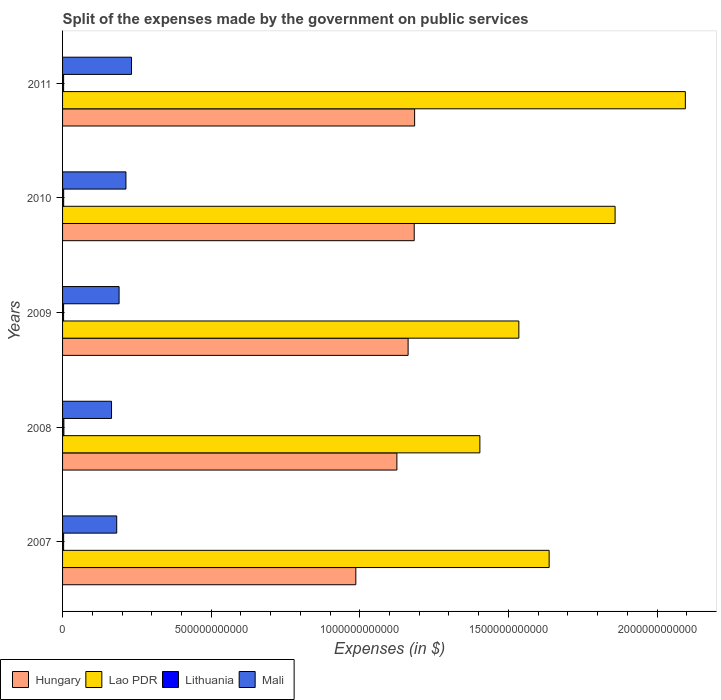How many different coloured bars are there?
Provide a succinct answer. 4. Are the number of bars per tick equal to the number of legend labels?
Make the answer very short. Yes. How many bars are there on the 4th tick from the bottom?
Your response must be concise. 4. What is the label of the 2nd group of bars from the top?
Provide a short and direct response. 2010. What is the expenses made by the government on public services in Mali in 2011?
Ensure brevity in your answer.  2.32e+11. Across all years, what is the maximum expenses made by the government on public services in Mali?
Keep it short and to the point. 2.32e+11. Across all years, what is the minimum expenses made by the government on public services in Lithuania?
Your answer should be very brief. 3.47e+09. In which year was the expenses made by the government on public services in Mali minimum?
Offer a terse response. 2008. What is the total expenses made by the government on public services in Mali in the graph?
Provide a short and direct response. 9.82e+11. What is the difference between the expenses made by the government on public services in Hungary in 2008 and that in 2009?
Give a very brief answer. -3.77e+1. What is the difference between the expenses made by the government on public services in Lithuania in 2010 and the expenses made by the government on public services in Hungary in 2007?
Provide a succinct answer. -9.83e+11. What is the average expenses made by the government on public services in Lao PDR per year?
Give a very brief answer. 1.71e+12. In the year 2008, what is the difference between the expenses made by the government on public services in Lao PDR and expenses made by the government on public services in Lithuania?
Ensure brevity in your answer.  1.40e+12. What is the ratio of the expenses made by the government on public services in Hungary in 2007 to that in 2011?
Provide a short and direct response. 0.83. Is the expenses made by the government on public services in Lao PDR in 2009 less than that in 2010?
Provide a short and direct response. Yes. Is the difference between the expenses made by the government on public services in Lao PDR in 2008 and 2011 greater than the difference between the expenses made by the government on public services in Lithuania in 2008 and 2011?
Offer a very short reply. No. What is the difference between the highest and the second highest expenses made by the government on public services in Lithuania?
Provide a short and direct response. 7.47e+08. What is the difference between the highest and the lowest expenses made by the government on public services in Lithuania?
Your answer should be compact. 9.76e+08. Is it the case that in every year, the sum of the expenses made by the government on public services in Mali and expenses made by the government on public services in Lao PDR is greater than the sum of expenses made by the government on public services in Hungary and expenses made by the government on public services in Lithuania?
Keep it short and to the point. Yes. What does the 3rd bar from the top in 2010 represents?
Your response must be concise. Lao PDR. What does the 3rd bar from the bottom in 2011 represents?
Provide a succinct answer. Lithuania. Is it the case that in every year, the sum of the expenses made by the government on public services in Lao PDR and expenses made by the government on public services in Lithuania is greater than the expenses made by the government on public services in Mali?
Keep it short and to the point. Yes. How many bars are there?
Make the answer very short. 20. Are all the bars in the graph horizontal?
Provide a succinct answer. Yes. What is the difference between two consecutive major ticks on the X-axis?
Give a very brief answer. 5.00e+11. What is the title of the graph?
Your answer should be compact. Split of the expenses made by the government on public services. What is the label or title of the X-axis?
Make the answer very short. Expenses (in $). What is the label or title of the Y-axis?
Give a very brief answer. Years. What is the Expenses (in $) of Hungary in 2007?
Your response must be concise. 9.87e+11. What is the Expenses (in $) in Lao PDR in 2007?
Offer a terse response. 1.64e+12. What is the Expenses (in $) in Lithuania in 2007?
Keep it short and to the point. 3.58e+09. What is the Expenses (in $) in Mali in 2007?
Your answer should be compact. 1.82e+11. What is the Expenses (in $) in Hungary in 2008?
Offer a terse response. 1.12e+12. What is the Expenses (in $) of Lao PDR in 2008?
Provide a succinct answer. 1.40e+12. What is the Expenses (in $) in Lithuania in 2008?
Offer a terse response. 4.44e+09. What is the Expenses (in $) of Mali in 2008?
Offer a terse response. 1.65e+11. What is the Expenses (in $) in Hungary in 2009?
Keep it short and to the point. 1.16e+12. What is the Expenses (in $) of Lao PDR in 2009?
Ensure brevity in your answer.  1.54e+12. What is the Expenses (in $) of Lithuania in 2009?
Keep it short and to the point. 3.47e+09. What is the Expenses (in $) of Mali in 2009?
Make the answer very short. 1.90e+11. What is the Expenses (in $) of Hungary in 2010?
Your answer should be very brief. 1.18e+12. What is the Expenses (in $) in Lao PDR in 2010?
Ensure brevity in your answer.  1.86e+12. What is the Expenses (in $) in Lithuania in 2010?
Your answer should be compact. 3.70e+09. What is the Expenses (in $) in Mali in 2010?
Your response must be concise. 2.13e+11. What is the Expenses (in $) of Hungary in 2011?
Give a very brief answer. 1.18e+12. What is the Expenses (in $) of Lao PDR in 2011?
Ensure brevity in your answer.  2.10e+12. What is the Expenses (in $) of Lithuania in 2011?
Offer a very short reply. 3.53e+09. What is the Expenses (in $) of Mali in 2011?
Your answer should be compact. 2.32e+11. Across all years, what is the maximum Expenses (in $) of Hungary?
Ensure brevity in your answer.  1.18e+12. Across all years, what is the maximum Expenses (in $) of Lao PDR?
Keep it short and to the point. 2.10e+12. Across all years, what is the maximum Expenses (in $) of Lithuania?
Offer a terse response. 4.44e+09. Across all years, what is the maximum Expenses (in $) of Mali?
Keep it short and to the point. 2.32e+11. Across all years, what is the minimum Expenses (in $) of Hungary?
Provide a short and direct response. 9.87e+11. Across all years, what is the minimum Expenses (in $) of Lao PDR?
Your answer should be compact. 1.40e+12. Across all years, what is the minimum Expenses (in $) of Lithuania?
Make the answer very short. 3.47e+09. Across all years, what is the minimum Expenses (in $) in Mali?
Provide a short and direct response. 1.65e+11. What is the total Expenses (in $) in Hungary in the graph?
Ensure brevity in your answer.  5.64e+12. What is the total Expenses (in $) in Lao PDR in the graph?
Offer a terse response. 8.53e+12. What is the total Expenses (in $) of Lithuania in the graph?
Keep it short and to the point. 1.87e+1. What is the total Expenses (in $) of Mali in the graph?
Provide a short and direct response. 9.82e+11. What is the difference between the Expenses (in $) of Hungary in 2007 and that in 2008?
Offer a terse response. -1.38e+11. What is the difference between the Expenses (in $) in Lao PDR in 2007 and that in 2008?
Provide a short and direct response. 2.33e+11. What is the difference between the Expenses (in $) in Lithuania in 2007 and that in 2008?
Offer a terse response. -8.61e+08. What is the difference between the Expenses (in $) of Mali in 2007 and that in 2008?
Your answer should be compact. 1.75e+1. What is the difference between the Expenses (in $) of Hungary in 2007 and that in 2009?
Your answer should be compact. -1.76e+11. What is the difference between the Expenses (in $) of Lao PDR in 2007 and that in 2009?
Your answer should be compact. 1.02e+11. What is the difference between the Expenses (in $) in Lithuania in 2007 and that in 2009?
Provide a short and direct response. 1.14e+08. What is the difference between the Expenses (in $) of Mali in 2007 and that in 2009?
Keep it short and to the point. -8.00e+09. What is the difference between the Expenses (in $) of Hungary in 2007 and that in 2010?
Your answer should be very brief. -1.96e+11. What is the difference between the Expenses (in $) in Lao PDR in 2007 and that in 2010?
Give a very brief answer. -2.22e+11. What is the difference between the Expenses (in $) in Lithuania in 2007 and that in 2010?
Provide a short and direct response. -1.14e+08. What is the difference between the Expenses (in $) of Mali in 2007 and that in 2010?
Provide a succinct answer. -3.10e+1. What is the difference between the Expenses (in $) of Hungary in 2007 and that in 2011?
Your answer should be very brief. -1.98e+11. What is the difference between the Expenses (in $) in Lao PDR in 2007 and that in 2011?
Provide a succinct answer. -4.58e+11. What is the difference between the Expenses (in $) of Lithuania in 2007 and that in 2011?
Make the answer very short. 4.96e+07. What is the difference between the Expenses (in $) of Mali in 2007 and that in 2011?
Provide a succinct answer. -4.98e+1. What is the difference between the Expenses (in $) of Hungary in 2008 and that in 2009?
Provide a short and direct response. -3.77e+1. What is the difference between the Expenses (in $) in Lao PDR in 2008 and that in 2009?
Offer a very short reply. -1.31e+11. What is the difference between the Expenses (in $) in Lithuania in 2008 and that in 2009?
Make the answer very short. 9.76e+08. What is the difference between the Expenses (in $) of Mali in 2008 and that in 2009?
Keep it short and to the point. -2.55e+1. What is the difference between the Expenses (in $) of Hungary in 2008 and that in 2010?
Your response must be concise. -5.83e+1. What is the difference between the Expenses (in $) in Lao PDR in 2008 and that in 2010?
Offer a very short reply. -4.55e+11. What is the difference between the Expenses (in $) in Lithuania in 2008 and that in 2010?
Keep it short and to the point. 7.47e+08. What is the difference between the Expenses (in $) of Mali in 2008 and that in 2010?
Your response must be concise. -4.85e+1. What is the difference between the Expenses (in $) in Hungary in 2008 and that in 2011?
Give a very brief answer. -5.97e+1. What is the difference between the Expenses (in $) of Lao PDR in 2008 and that in 2011?
Ensure brevity in your answer.  -6.91e+11. What is the difference between the Expenses (in $) of Lithuania in 2008 and that in 2011?
Your answer should be very brief. 9.11e+08. What is the difference between the Expenses (in $) of Mali in 2008 and that in 2011?
Provide a short and direct response. -6.72e+1. What is the difference between the Expenses (in $) of Hungary in 2009 and that in 2010?
Offer a very short reply. -2.05e+1. What is the difference between the Expenses (in $) of Lao PDR in 2009 and that in 2010?
Make the answer very short. -3.24e+11. What is the difference between the Expenses (in $) of Lithuania in 2009 and that in 2010?
Your answer should be compact. -2.29e+08. What is the difference between the Expenses (in $) in Mali in 2009 and that in 2010?
Provide a succinct answer. -2.30e+1. What is the difference between the Expenses (in $) in Hungary in 2009 and that in 2011?
Your answer should be compact. -2.19e+1. What is the difference between the Expenses (in $) in Lao PDR in 2009 and that in 2011?
Provide a short and direct response. -5.60e+11. What is the difference between the Expenses (in $) in Lithuania in 2009 and that in 2011?
Your answer should be very brief. -6.47e+07. What is the difference between the Expenses (in $) of Mali in 2009 and that in 2011?
Your response must be concise. -4.18e+1. What is the difference between the Expenses (in $) in Hungary in 2010 and that in 2011?
Make the answer very short. -1.40e+09. What is the difference between the Expenses (in $) in Lao PDR in 2010 and that in 2011?
Ensure brevity in your answer.  -2.36e+11. What is the difference between the Expenses (in $) in Lithuania in 2010 and that in 2011?
Offer a very short reply. 1.64e+08. What is the difference between the Expenses (in $) of Mali in 2010 and that in 2011?
Provide a short and direct response. -1.88e+1. What is the difference between the Expenses (in $) in Hungary in 2007 and the Expenses (in $) in Lao PDR in 2008?
Make the answer very short. -4.17e+11. What is the difference between the Expenses (in $) of Hungary in 2007 and the Expenses (in $) of Lithuania in 2008?
Your answer should be very brief. 9.82e+11. What is the difference between the Expenses (in $) of Hungary in 2007 and the Expenses (in $) of Mali in 2008?
Offer a very short reply. 8.22e+11. What is the difference between the Expenses (in $) in Lao PDR in 2007 and the Expenses (in $) in Lithuania in 2008?
Your response must be concise. 1.63e+12. What is the difference between the Expenses (in $) in Lao PDR in 2007 and the Expenses (in $) in Mali in 2008?
Provide a short and direct response. 1.47e+12. What is the difference between the Expenses (in $) of Lithuania in 2007 and the Expenses (in $) of Mali in 2008?
Provide a short and direct response. -1.61e+11. What is the difference between the Expenses (in $) of Hungary in 2007 and the Expenses (in $) of Lao PDR in 2009?
Your answer should be very brief. -5.48e+11. What is the difference between the Expenses (in $) in Hungary in 2007 and the Expenses (in $) in Lithuania in 2009?
Your response must be concise. 9.83e+11. What is the difference between the Expenses (in $) in Hungary in 2007 and the Expenses (in $) in Mali in 2009?
Your response must be concise. 7.96e+11. What is the difference between the Expenses (in $) of Lao PDR in 2007 and the Expenses (in $) of Lithuania in 2009?
Give a very brief answer. 1.63e+12. What is the difference between the Expenses (in $) in Lao PDR in 2007 and the Expenses (in $) in Mali in 2009?
Your answer should be very brief. 1.45e+12. What is the difference between the Expenses (in $) of Lithuania in 2007 and the Expenses (in $) of Mali in 2009?
Offer a very short reply. -1.87e+11. What is the difference between the Expenses (in $) of Hungary in 2007 and the Expenses (in $) of Lao PDR in 2010?
Provide a short and direct response. -8.72e+11. What is the difference between the Expenses (in $) in Hungary in 2007 and the Expenses (in $) in Lithuania in 2010?
Offer a very short reply. 9.83e+11. What is the difference between the Expenses (in $) in Hungary in 2007 and the Expenses (in $) in Mali in 2010?
Your answer should be very brief. 7.73e+11. What is the difference between the Expenses (in $) in Lao PDR in 2007 and the Expenses (in $) in Lithuania in 2010?
Provide a short and direct response. 1.63e+12. What is the difference between the Expenses (in $) of Lao PDR in 2007 and the Expenses (in $) of Mali in 2010?
Ensure brevity in your answer.  1.42e+12. What is the difference between the Expenses (in $) of Lithuania in 2007 and the Expenses (in $) of Mali in 2010?
Your answer should be very brief. -2.10e+11. What is the difference between the Expenses (in $) of Hungary in 2007 and the Expenses (in $) of Lao PDR in 2011?
Your answer should be compact. -1.11e+12. What is the difference between the Expenses (in $) of Hungary in 2007 and the Expenses (in $) of Lithuania in 2011?
Provide a succinct answer. 9.83e+11. What is the difference between the Expenses (in $) in Hungary in 2007 and the Expenses (in $) in Mali in 2011?
Keep it short and to the point. 7.55e+11. What is the difference between the Expenses (in $) of Lao PDR in 2007 and the Expenses (in $) of Lithuania in 2011?
Make the answer very short. 1.63e+12. What is the difference between the Expenses (in $) in Lao PDR in 2007 and the Expenses (in $) in Mali in 2011?
Make the answer very short. 1.40e+12. What is the difference between the Expenses (in $) in Lithuania in 2007 and the Expenses (in $) in Mali in 2011?
Offer a very short reply. -2.28e+11. What is the difference between the Expenses (in $) in Hungary in 2008 and the Expenses (in $) in Lao PDR in 2009?
Keep it short and to the point. -4.10e+11. What is the difference between the Expenses (in $) of Hungary in 2008 and the Expenses (in $) of Lithuania in 2009?
Provide a succinct answer. 1.12e+12. What is the difference between the Expenses (in $) of Hungary in 2008 and the Expenses (in $) of Mali in 2009?
Provide a succinct answer. 9.35e+11. What is the difference between the Expenses (in $) of Lao PDR in 2008 and the Expenses (in $) of Lithuania in 2009?
Offer a very short reply. 1.40e+12. What is the difference between the Expenses (in $) in Lao PDR in 2008 and the Expenses (in $) in Mali in 2009?
Give a very brief answer. 1.21e+12. What is the difference between the Expenses (in $) of Lithuania in 2008 and the Expenses (in $) of Mali in 2009?
Provide a short and direct response. -1.86e+11. What is the difference between the Expenses (in $) in Hungary in 2008 and the Expenses (in $) in Lao PDR in 2010?
Provide a short and direct response. -7.34e+11. What is the difference between the Expenses (in $) in Hungary in 2008 and the Expenses (in $) in Lithuania in 2010?
Provide a short and direct response. 1.12e+12. What is the difference between the Expenses (in $) in Hungary in 2008 and the Expenses (in $) in Mali in 2010?
Ensure brevity in your answer.  9.12e+11. What is the difference between the Expenses (in $) of Lao PDR in 2008 and the Expenses (in $) of Lithuania in 2010?
Provide a short and direct response. 1.40e+12. What is the difference between the Expenses (in $) in Lao PDR in 2008 and the Expenses (in $) in Mali in 2010?
Give a very brief answer. 1.19e+12. What is the difference between the Expenses (in $) of Lithuania in 2008 and the Expenses (in $) of Mali in 2010?
Your answer should be compact. -2.09e+11. What is the difference between the Expenses (in $) in Hungary in 2008 and the Expenses (in $) in Lao PDR in 2011?
Provide a short and direct response. -9.70e+11. What is the difference between the Expenses (in $) of Hungary in 2008 and the Expenses (in $) of Lithuania in 2011?
Keep it short and to the point. 1.12e+12. What is the difference between the Expenses (in $) of Hungary in 2008 and the Expenses (in $) of Mali in 2011?
Your answer should be very brief. 8.93e+11. What is the difference between the Expenses (in $) in Lao PDR in 2008 and the Expenses (in $) in Lithuania in 2011?
Provide a succinct answer. 1.40e+12. What is the difference between the Expenses (in $) in Lao PDR in 2008 and the Expenses (in $) in Mali in 2011?
Make the answer very short. 1.17e+12. What is the difference between the Expenses (in $) of Lithuania in 2008 and the Expenses (in $) of Mali in 2011?
Give a very brief answer. -2.28e+11. What is the difference between the Expenses (in $) of Hungary in 2009 and the Expenses (in $) of Lao PDR in 2010?
Your answer should be compact. -6.96e+11. What is the difference between the Expenses (in $) of Hungary in 2009 and the Expenses (in $) of Lithuania in 2010?
Offer a very short reply. 1.16e+12. What is the difference between the Expenses (in $) in Hungary in 2009 and the Expenses (in $) in Mali in 2010?
Ensure brevity in your answer.  9.49e+11. What is the difference between the Expenses (in $) of Lao PDR in 2009 and the Expenses (in $) of Lithuania in 2010?
Your answer should be compact. 1.53e+12. What is the difference between the Expenses (in $) in Lao PDR in 2009 and the Expenses (in $) in Mali in 2010?
Make the answer very short. 1.32e+12. What is the difference between the Expenses (in $) in Lithuania in 2009 and the Expenses (in $) in Mali in 2010?
Give a very brief answer. -2.10e+11. What is the difference between the Expenses (in $) of Hungary in 2009 and the Expenses (in $) of Lao PDR in 2011?
Keep it short and to the point. -9.33e+11. What is the difference between the Expenses (in $) of Hungary in 2009 and the Expenses (in $) of Lithuania in 2011?
Provide a succinct answer. 1.16e+12. What is the difference between the Expenses (in $) of Hungary in 2009 and the Expenses (in $) of Mali in 2011?
Your response must be concise. 9.31e+11. What is the difference between the Expenses (in $) of Lao PDR in 2009 and the Expenses (in $) of Lithuania in 2011?
Your answer should be very brief. 1.53e+12. What is the difference between the Expenses (in $) of Lao PDR in 2009 and the Expenses (in $) of Mali in 2011?
Provide a succinct answer. 1.30e+12. What is the difference between the Expenses (in $) of Lithuania in 2009 and the Expenses (in $) of Mali in 2011?
Ensure brevity in your answer.  -2.29e+11. What is the difference between the Expenses (in $) of Hungary in 2010 and the Expenses (in $) of Lao PDR in 2011?
Your answer should be compact. -9.12e+11. What is the difference between the Expenses (in $) of Hungary in 2010 and the Expenses (in $) of Lithuania in 2011?
Provide a short and direct response. 1.18e+12. What is the difference between the Expenses (in $) of Hungary in 2010 and the Expenses (in $) of Mali in 2011?
Give a very brief answer. 9.51e+11. What is the difference between the Expenses (in $) of Lao PDR in 2010 and the Expenses (in $) of Lithuania in 2011?
Offer a very short reply. 1.86e+12. What is the difference between the Expenses (in $) in Lao PDR in 2010 and the Expenses (in $) in Mali in 2011?
Your answer should be compact. 1.63e+12. What is the difference between the Expenses (in $) in Lithuania in 2010 and the Expenses (in $) in Mali in 2011?
Your response must be concise. -2.28e+11. What is the average Expenses (in $) in Hungary per year?
Provide a short and direct response. 1.13e+12. What is the average Expenses (in $) in Lao PDR per year?
Give a very brief answer. 1.71e+12. What is the average Expenses (in $) of Lithuania per year?
Keep it short and to the point. 3.74e+09. What is the average Expenses (in $) of Mali per year?
Give a very brief answer. 1.96e+11. In the year 2007, what is the difference between the Expenses (in $) of Hungary and Expenses (in $) of Lao PDR?
Make the answer very short. -6.50e+11. In the year 2007, what is the difference between the Expenses (in $) of Hungary and Expenses (in $) of Lithuania?
Your answer should be very brief. 9.83e+11. In the year 2007, what is the difference between the Expenses (in $) in Hungary and Expenses (in $) in Mali?
Give a very brief answer. 8.04e+11. In the year 2007, what is the difference between the Expenses (in $) of Lao PDR and Expenses (in $) of Lithuania?
Ensure brevity in your answer.  1.63e+12. In the year 2007, what is the difference between the Expenses (in $) in Lao PDR and Expenses (in $) in Mali?
Your answer should be very brief. 1.45e+12. In the year 2007, what is the difference between the Expenses (in $) in Lithuania and Expenses (in $) in Mali?
Provide a short and direct response. -1.79e+11. In the year 2008, what is the difference between the Expenses (in $) of Hungary and Expenses (in $) of Lao PDR?
Your response must be concise. -2.79e+11. In the year 2008, what is the difference between the Expenses (in $) in Hungary and Expenses (in $) in Lithuania?
Provide a short and direct response. 1.12e+12. In the year 2008, what is the difference between the Expenses (in $) in Hungary and Expenses (in $) in Mali?
Your answer should be compact. 9.60e+11. In the year 2008, what is the difference between the Expenses (in $) of Lao PDR and Expenses (in $) of Lithuania?
Offer a very short reply. 1.40e+12. In the year 2008, what is the difference between the Expenses (in $) of Lao PDR and Expenses (in $) of Mali?
Provide a succinct answer. 1.24e+12. In the year 2008, what is the difference between the Expenses (in $) in Lithuania and Expenses (in $) in Mali?
Offer a very short reply. -1.60e+11. In the year 2009, what is the difference between the Expenses (in $) in Hungary and Expenses (in $) in Lao PDR?
Offer a very short reply. -3.73e+11. In the year 2009, what is the difference between the Expenses (in $) in Hungary and Expenses (in $) in Lithuania?
Your answer should be compact. 1.16e+12. In the year 2009, what is the difference between the Expenses (in $) of Hungary and Expenses (in $) of Mali?
Your answer should be compact. 9.72e+11. In the year 2009, what is the difference between the Expenses (in $) of Lao PDR and Expenses (in $) of Lithuania?
Provide a short and direct response. 1.53e+12. In the year 2009, what is the difference between the Expenses (in $) of Lao PDR and Expenses (in $) of Mali?
Ensure brevity in your answer.  1.34e+12. In the year 2009, what is the difference between the Expenses (in $) in Lithuania and Expenses (in $) in Mali?
Give a very brief answer. -1.87e+11. In the year 2010, what is the difference between the Expenses (in $) in Hungary and Expenses (in $) in Lao PDR?
Provide a short and direct response. -6.76e+11. In the year 2010, what is the difference between the Expenses (in $) in Hungary and Expenses (in $) in Lithuania?
Ensure brevity in your answer.  1.18e+12. In the year 2010, what is the difference between the Expenses (in $) in Hungary and Expenses (in $) in Mali?
Make the answer very short. 9.70e+11. In the year 2010, what is the difference between the Expenses (in $) in Lao PDR and Expenses (in $) in Lithuania?
Provide a succinct answer. 1.86e+12. In the year 2010, what is the difference between the Expenses (in $) of Lao PDR and Expenses (in $) of Mali?
Your answer should be compact. 1.65e+12. In the year 2010, what is the difference between the Expenses (in $) of Lithuania and Expenses (in $) of Mali?
Ensure brevity in your answer.  -2.09e+11. In the year 2011, what is the difference between the Expenses (in $) in Hungary and Expenses (in $) in Lao PDR?
Offer a terse response. -9.11e+11. In the year 2011, what is the difference between the Expenses (in $) of Hungary and Expenses (in $) of Lithuania?
Make the answer very short. 1.18e+12. In the year 2011, what is the difference between the Expenses (in $) in Hungary and Expenses (in $) in Mali?
Make the answer very short. 9.52e+11. In the year 2011, what is the difference between the Expenses (in $) of Lao PDR and Expenses (in $) of Lithuania?
Make the answer very short. 2.09e+12. In the year 2011, what is the difference between the Expenses (in $) of Lao PDR and Expenses (in $) of Mali?
Offer a terse response. 1.86e+12. In the year 2011, what is the difference between the Expenses (in $) of Lithuania and Expenses (in $) of Mali?
Provide a short and direct response. -2.28e+11. What is the ratio of the Expenses (in $) of Hungary in 2007 to that in 2008?
Provide a succinct answer. 0.88. What is the ratio of the Expenses (in $) in Lao PDR in 2007 to that in 2008?
Keep it short and to the point. 1.17. What is the ratio of the Expenses (in $) of Lithuania in 2007 to that in 2008?
Provide a succinct answer. 0.81. What is the ratio of the Expenses (in $) in Mali in 2007 to that in 2008?
Ensure brevity in your answer.  1.11. What is the ratio of the Expenses (in $) in Hungary in 2007 to that in 2009?
Your answer should be very brief. 0.85. What is the ratio of the Expenses (in $) of Lao PDR in 2007 to that in 2009?
Keep it short and to the point. 1.07. What is the ratio of the Expenses (in $) of Lithuania in 2007 to that in 2009?
Provide a short and direct response. 1.03. What is the ratio of the Expenses (in $) of Mali in 2007 to that in 2009?
Offer a terse response. 0.96. What is the ratio of the Expenses (in $) in Hungary in 2007 to that in 2010?
Offer a very short reply. 0.83. What is the ratio of the Expenses (in $) in Lao PDR in 2007 to that in 2010?
Offer a terse response. 0.88. What is the ratio of the Expenses (in $) of Lithuania in 2007 to that in 2010?
Your answer should be very brief. 0.97. What is the ratio of the Expenses (in $) of Mali in 2007 to that in 2010?
Your answer should be compact. 0.85. What is the ratio of the Expenses (in $) in Hungary in 2007 to that in 2011?
Offer a terse response. 0.83. What is the ratio of the Expenses (in $) of Lao PDR in 2007 to that in 2011?
Your response must be concise. 0.78. What is the ratio of the Expenses (in $) in Lithuania in 2007 to that in 2011?
Your answer should be very brief. 1.01. What is the ratio of the Expenses (in $) of Mali in 2007 to that in 2011?
Provide a succinct answer. 0.79. What is the ratio of the Expenses (in $) in Hungary in 2008 to that in 2009?
Make the answer very short. 0.97. What is the ratio of the Expenses (in $) of Lao PDR in 2008 to that in 2009?
Give a very brief answer. 0.91. What is the ratio of the Expenses (in $) of Lithuania in 2008 to that in 2009?
Offer a very short reply. 1.28. What is the ratio of the Expenses (in $) in Mali in 2008 to that in 2009?
Provide a succinct answer. 0.87. What is the ratio of the Expenses (in $) in Hungary in 2008 to that in 2010?
Ensure brevity in your answer.  0.95. What is the ratio of the Expenses (in $) of Lao PDR in 2008 to that in 2010?
Make the answer very short. 0.76. What is the ratio of the Expenses (in $) of Lithuania in 2008 to that in 2010?
Provide a succinct answer. 1.2. What is the ratio of the Expenses (in $) in Mali in 2008 to that in 2010?
Your answer should be compact. 0.77. What is the ratio of the Expenses (in $) in Hungary in 2008 to that in 2011?
Your response must be concise. 0.95. What is the ratio of the Expenses (in $) of Lao PDR in 2008 to that in 2011?
Your answer should be compact. 0.67. What is the ratio of the Expenses (in $) in Lithuania in 2008 to that in 2011?
Make the answer very short. 1.26. What is the ratio of the Expenses (in $) of Mali in 2008 to that in 2011?
Provide a short and direct response. 0.71. What is the ratio of the Expenses (in $) in Hungary in 2009 to that in 2010?
Your response must be concise. 0.98. What is the ratio of the Expenses (in $) in Lao PDR in 2009 to that in 2010?
Offer a terse response. 0.83. What is the ratio of the Expenses (in $) in Lithuania in 2009 to that in 2010?
Give a very brief answer. 0.94. What is the ratio of the Expenses (in $) of Mali in 2009 to that in 2010?
Your response must be concise. 0.89. What is the ratio of the Expenses (in $) of Hungary in 2009 to that in 2011?
Provide a succinct answer. 0.98. What is the ratio of the Expenses (in $) in Lao PDR in 2009 to that in 2011?
Offer a very short reply. 0.73. What is the ratio of the Expenses (in $) in Lithuania in 2009 to that in 2011?
Offer a terse response. 0.98. What is the ratio of the Expenses (in $) of Mali in 2009 to that in 2011?
Provide a short and direct response. 0.82. What is the ratio of the Expenses (in $) of Lao PDR in 2010 to that in 2011?
Provide a succinct answer. 0.89. What is the ratio of the Expenses (in $) in Lithuania in 2010 to that in 2011?
Your answer should be very brief. 1.05. What is the ratio of the Expenses (in $) in Mali in 2010 to that in 2011?
Provide a short and direct response. 0.92. What is the difference between the highest and the second highest Expenses (in $) of Hungary?
Keep it short and to the point. 1.40e+09. What is the difference between the highest and the second highest Expenses (in $) in Lao PDR?
Provide a succinct answer. 2.36e+11. What is the difference between the highest and the second highest Expenses (in $) in Lithuania?
Give a very brief answer. 7.47e+08. What is the difference between the highest and the second highest Expenses (in $) of Mali?
Your answer should be very brief. 1.88e+1. What is the difference between the highest and the lowest Expenses (in $) of Hungary?
Offer a terse response. 1.98e+11. What is the difference between the highest and the lowest Expenses (in $) of Lao PDR?
Ensure brevity in your answer.  6.91e+11. What is the difference between the highest and the lowest Expenses (in $) in Lithuania?
Ensure brevity in your answer.  9.76e+08. What is the difference between the highest and the lowest Expenses (in $) of Mali?
Provide a succinct answer. 6.72e+1. 